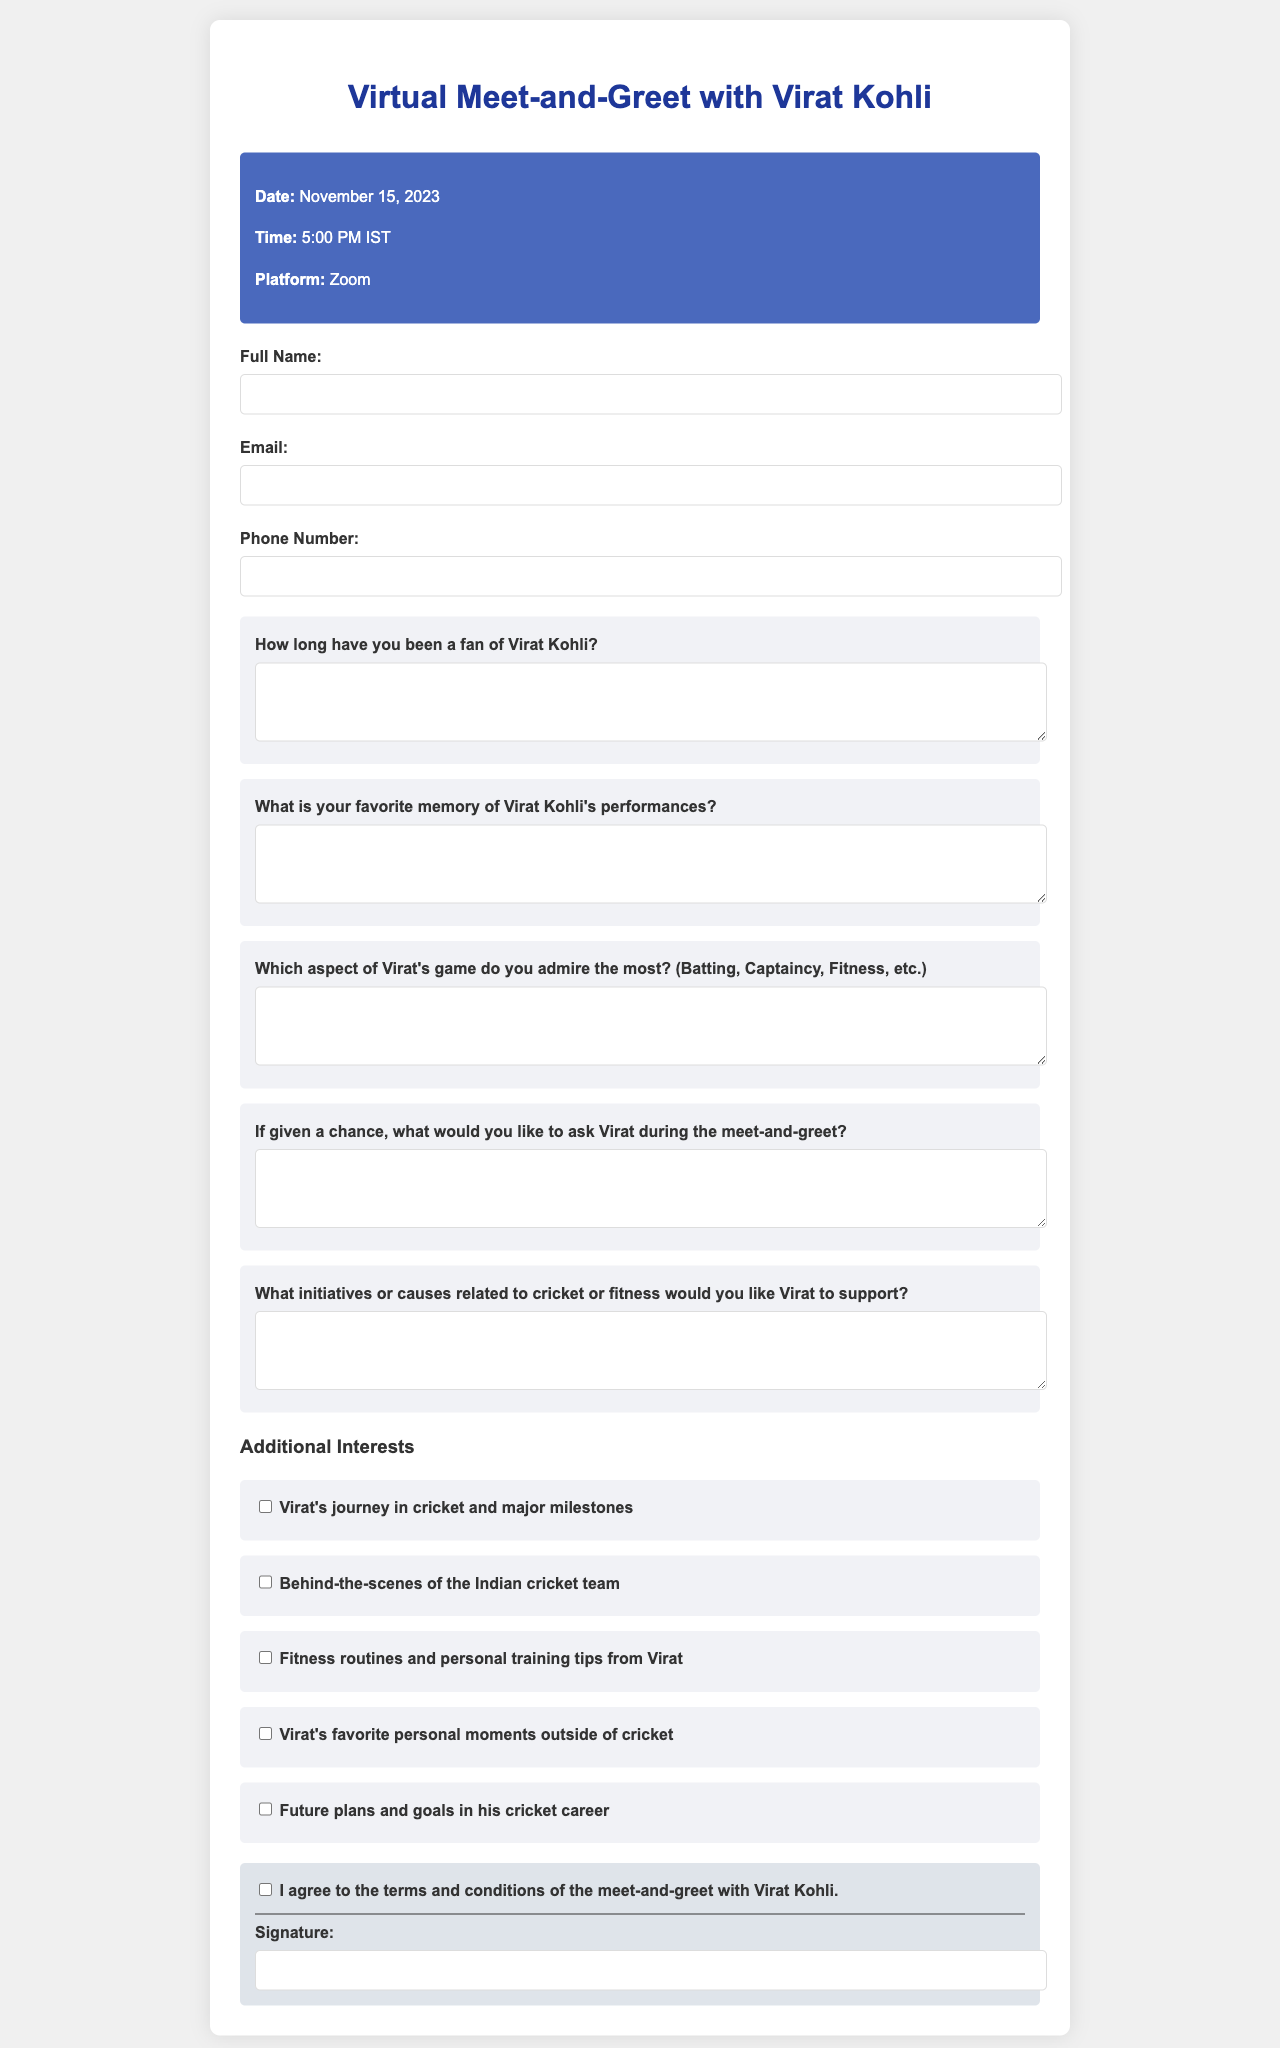What is the date of the virtual meet-and-greet session? The date is specified in the event details section of the document.
Answer: November 15, 2023 What is the time of the event? The time is mentioned alongside the date in the event details.
Answer: 5:00 PM IST Which platform will be used for the session? The platform for the virtual meet-and-greet is indicated in the document.
Answer: Zoom What is one of the questions participants need to answer regarding their fandom? Participants are required to provide their thoughts on various aspects of their fandom in the questions section.
Answer: How long have you been a fan of Virat Kohli? What is one of the interests that participants can select? The document lists various additional interests that participants can express, linked to Virat Kohli.
Answer: Virat's journey in cricket and major milestones What do participants need to include as a legal formality in the agreement? There is a requirement for participants to agree to specific terms laid out in the document.
Answer: I agree to the terms and conditions of the meet-and-greet with Virat Kohli What type of information is required in the "Phone Number" field? The document specifies the type of input expected in particular fields in the form.
Answer: Telephone number What do participants need to provide at the end of the form? The document specifies a requirement for a specific type of input from the participant at the end of the form.
Answer: Signature 